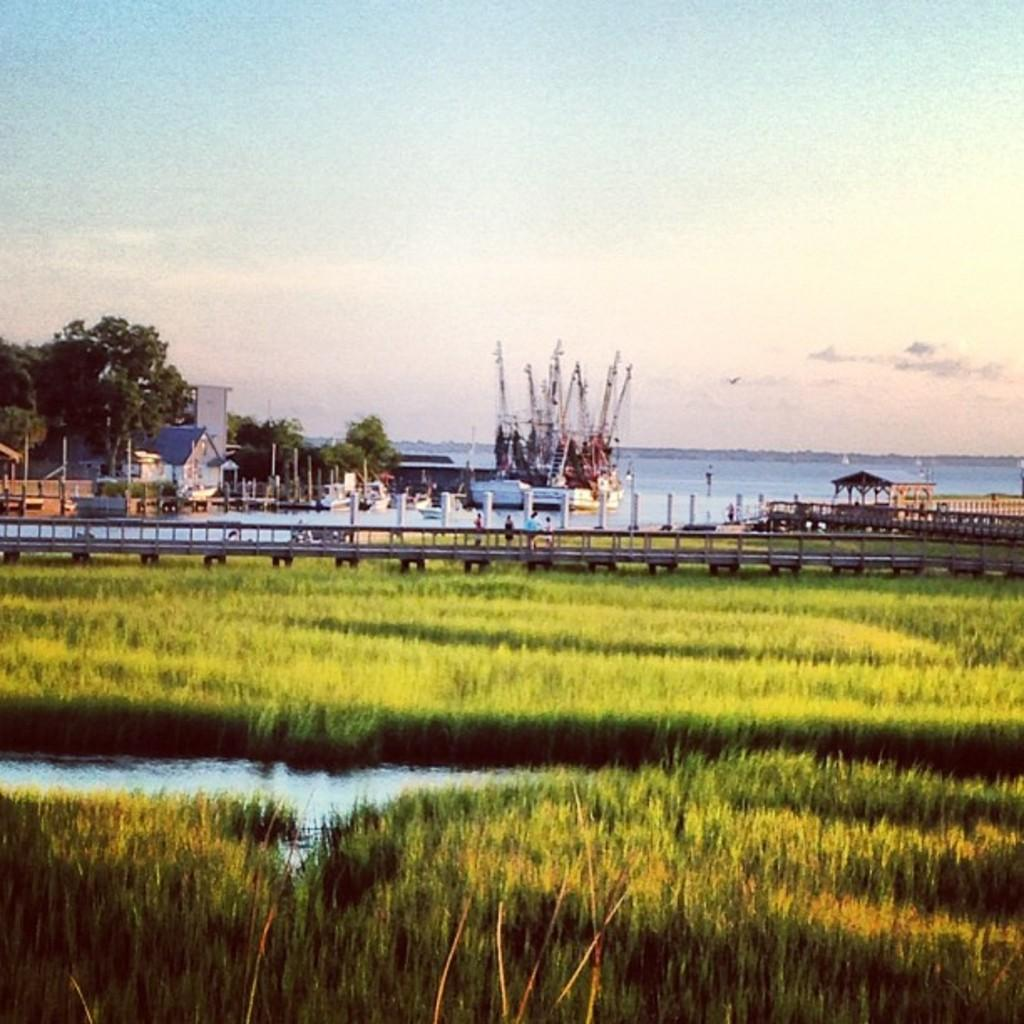What type of vegetation can be seen in the image? There is grass in the image. What type of structure is present in the image? There is a bridge in the image. What other natural elements are present in the image? Trees are present in the image. What man-made objects can be seen in the image? Poles are visible in the image. What type of building is in the image? There is a house in the image. What mode of transportation is present in the image? A ship is present in the image. What natural feature is visible in the image? There is water visible in the image. What can be seen in the background of the image? The sky is visible in the background of the image. What type of waste is being disposed of in the image? There is no waste disposal present in the image. What type of writing instrument is being used by the pet in the image? There is no pet or writing instrument present in the image. 